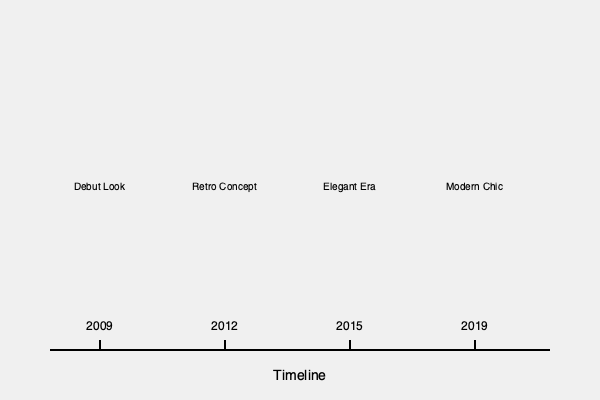Analyze the fashion evolution of Hahm Eun-Jung as depicted in the timeline infographic. Which year marked a significant shift towards a more sophisticated and mature style, and what factors might have influenced this change in her fashion choices? To answer this question, let's examine Hahm Eun-Jung's fashion evolution step-by-step:

1. 2009 (Debut Look): This represents Hahm Eun-Jung's initial style at the beginning of her career. It likely featured youthful and trendy elements typical of K-pop idol fashion at that time.

2. 2012 (Retro Concept): This era shows a shift towards a retro-inspired style, possibly influenced by the popularity of vintage concepts in K-pop during this period.

3. 2015 (Elegant Era): This marks a significant change in Hahm Eun-Jung's style. The term "Elegant Era" suggests a move towards more sophisticated and mature fashion choices. This shift could be attributed to:
   a) Her growth as an artist and individual
   b) A desire to present a more adult image as she entered her mid-20s
   c) Possible changes in her career focus or personal brand

4. 2019 (Modern Chic): This represents a continuation and refinement of the elegant style, incorporating contemporary fashion trends.

The most significant shift towards a sophisticated and mature style occurred in 2015. This change likely reflected Hahm Eun-Jung's personal growth, evolving career aspirations, and the natural progression of her public image as she transitioned from a young idol to an established artist in her mid-20s.
Answer: 2015 